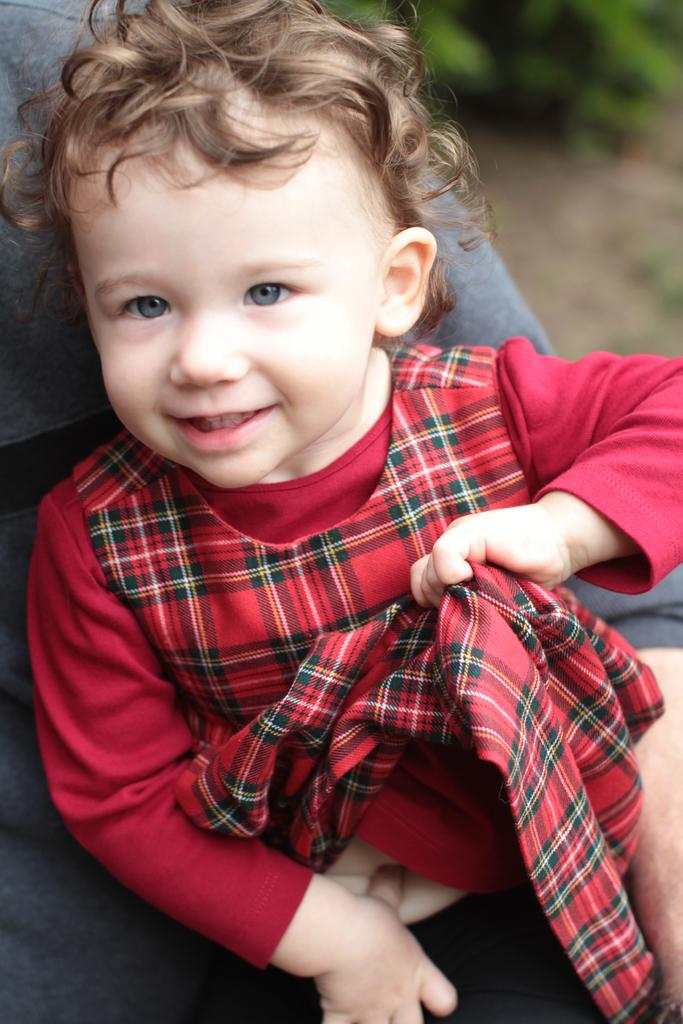How many people are present in the image? There are two persons in the image. What is the girl wearing in the image? One girl is wearing a red dress in the image. What is the other person wearing in the image? The other person is wearing a grey dress in the image. What can be seen in the background of the image? There are plants in the background of the image. Who is guiding the group of people in the image? There is no group of people in the image, and no one is guiding anyone. What type of floor can be seen in the image? There is no floor visible in the image; it only shows two people and plants in the background. 